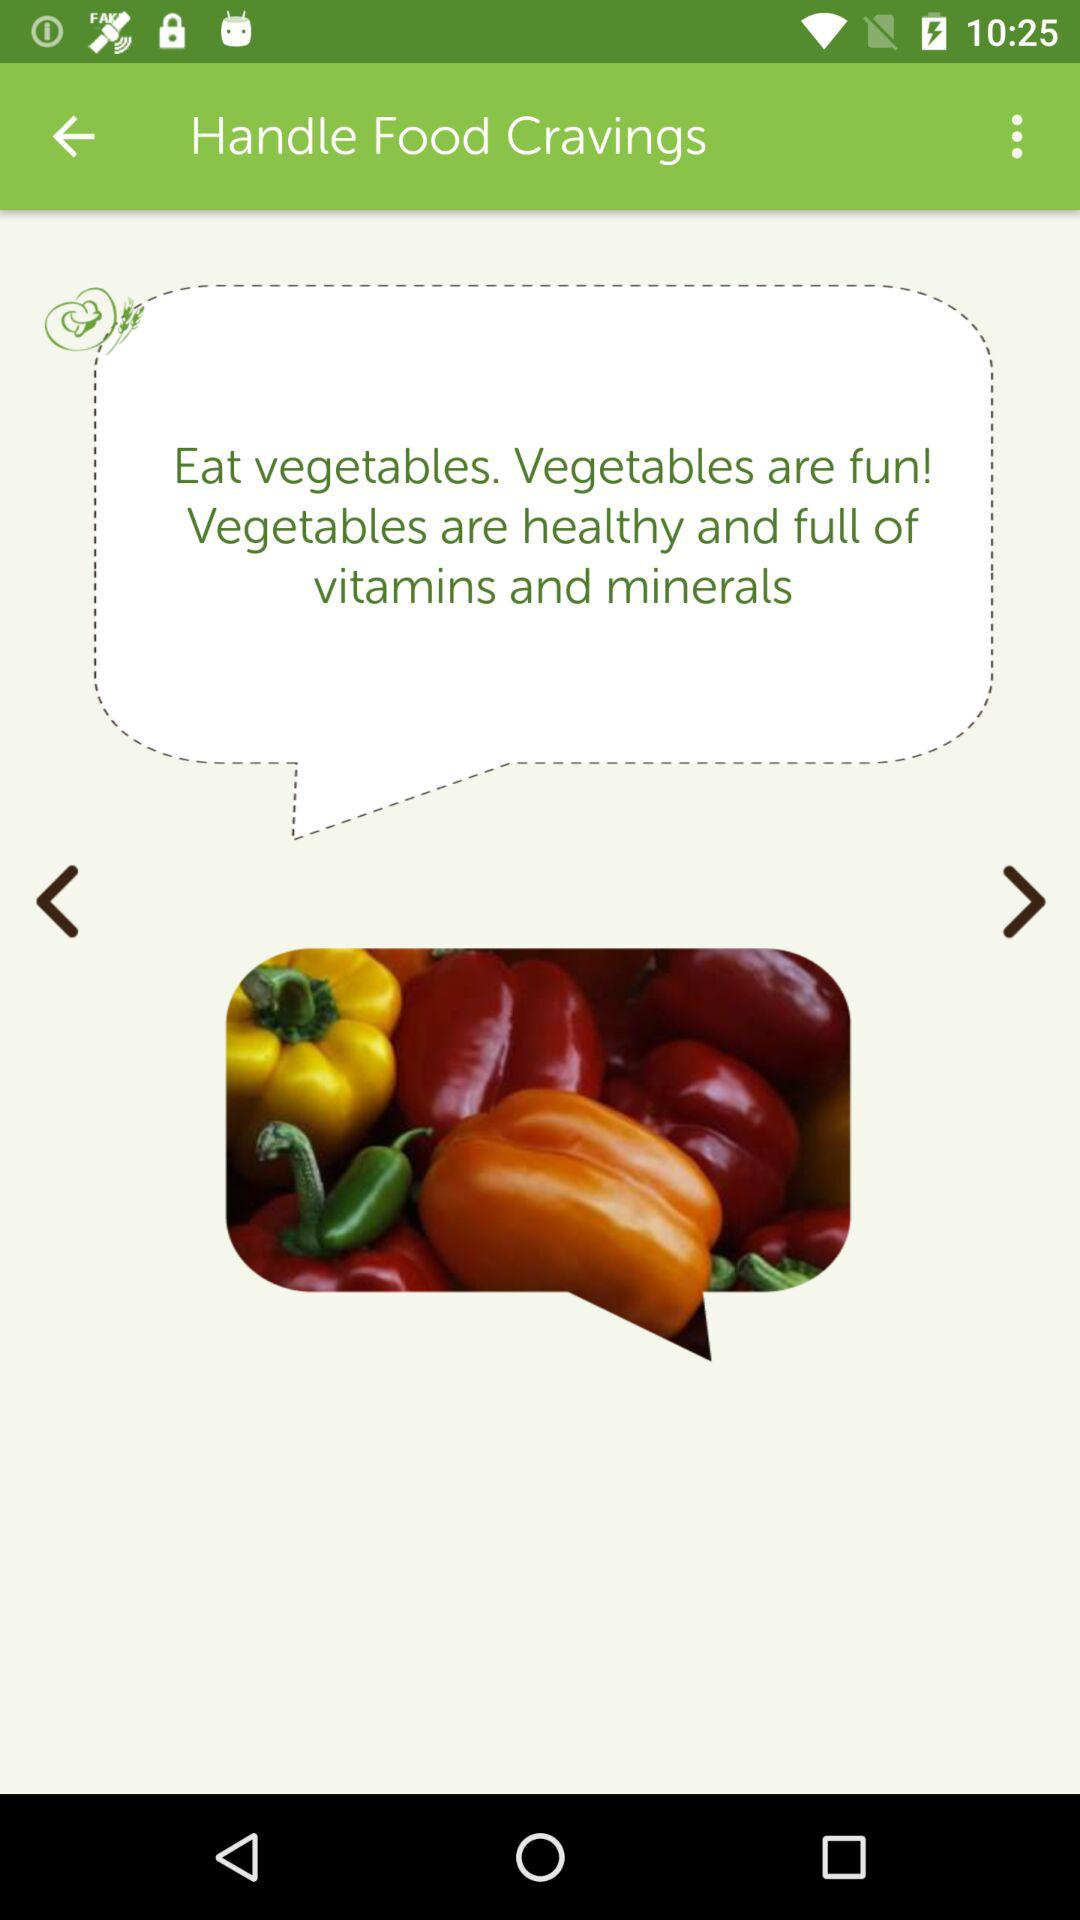What are the nutrients contained in vegetables? The nutrients contained in vegetables are vitamins and minerals. 